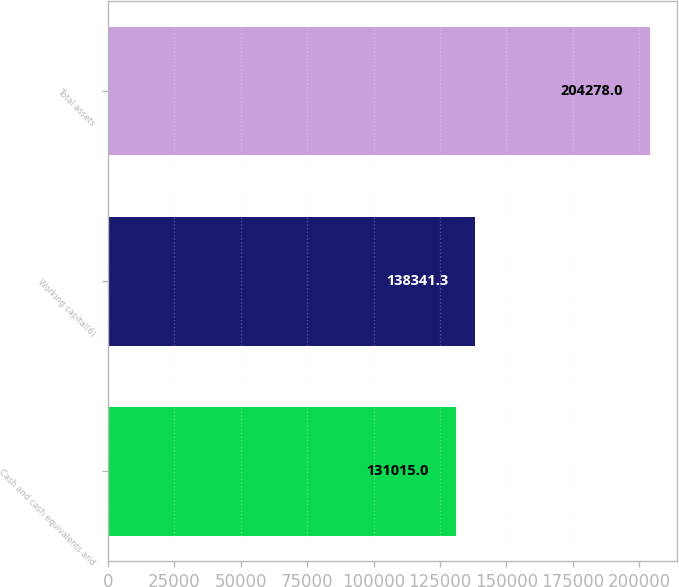Convert chart. <chart><loc_0><loc_0><loc_500><loc_500><bar_chart><fcel>Cash and cash equivalents and<fcel>Working capital(6)<fcel>Total assets<nl><fcel>131015<fcel>138341<fcel>204278<nl></chart> 